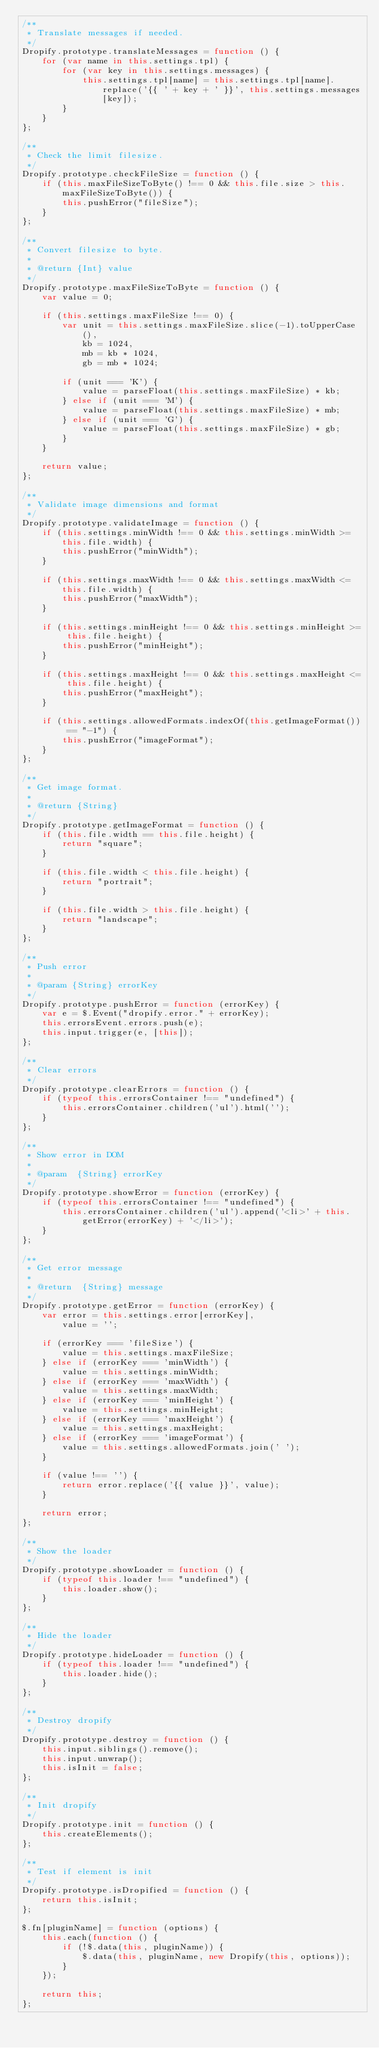<code> <loc_0><loc_0><loc_500><loc_500><_JavaScript_>/**
 * Translate messages if needed.
 */
Dropify.prototype.translateMessages = function () {
	for (var name in this.settings.tpl) {
		for (var key in this.settings.messages) {
			this.settings.tpl[name] = this.settings.tpl[name].replace('{{ ' + key + ' }}', this.settings.messages[key]);
		}
	}
};

/**
 * Check the limit filesize.
 */
Dropify.prototype.checkFileSize = function () {
	if (this.maxFileSizeToByte() !== 0 && this.file.size > this.maxFileSizeToByte()) {
		this.pushError("fileSize");
	}
};

/**
 * Convert filesize to byte.
 *
 * @return {Int} value
 */
Dropify.prototype.maxFileSizeToByte = function () {
	var value = 0;

	if (this.settings.maxFileSize !== 0) {
		var unit = this.settings.maxFileSize.slice(-1).toUpperCase(),
			kb = 1024,
			mb = kb * 1024,
			gb = mb * 1024;

		if (unit === 'K') {
			value = parseFloat(this.settings.maxFileSize) * kb;
		} else if (unit === 'M') {
			value = parseFloat(this.settings.maxFileSize) * mb;
		} else if (unit === 'G') {
			value = parseFloat(this.settings.maxFileSize) * gb;
		}
	}

	return value;
};

/**
 * Validate image dimensions and format
 */
Dropify.prototype.validateImage = function () {
	if (this.settings.minWidth !== 0 && this.settings.minWidth >= this.file.width) {
		this.pushError("minWidth");
	}

	if (this.settings.maxWidth !== 0 && this.settings.maxWidth <= this.file.width) {
		this.pushError("maxWidth");
	}

	if (this.settings.minHeight !== 0 && this.settings.minHeight >= this.file.height) {
		this.pushError("minHeight");
	}

	if (this.settings.maxHeight !== 0 && this.settings.maxHeight <= this.file.height) {
		this.pushError("maxHeight");
	}

	if (this.settings.allowedFormats.indexOf(this.getImageFormat()) == "-1") {
		this.pushError("imageFormat");
	}
};

/**
 * Get image format.
 *
 * @return {String}
 */
Dropify.prototype.getImageFormat = function () {
	if (this.file.width == this.file.height) {
		return "square";
	}

	if (this.file.width < this.file.height) {
		return "portrait";
	}

	if (this.file.width > this.file.height) {
		return "landscape";
	}
};

/**
 * Push error
 *
 * @param {String} errorKey
 */
Dropify.prototype.pushError = function (errorKey) {
	var e = $.Event("dropify.error." + errorKey);
	this.errorsEvent.errors.push(e);
	this.input.trigger(e, [this]);
};

/**
 * Clear errors
 */
Dropify.prototype.clearErrors = function () {
	if (typeof this.errorsContainer !== "undefined") {
		this.errorsContainer.children('ul').html('');
	}
};

/**
 * Show error in DOM
 *
 * @param  {String} errorKey
 */
Dropify.prototype.showError = function (errorKey) {
	if (typeof this.errorsContainer !== "undefined") {
		this.errorsContainer.children('ul').append('<li>' + this.getError(errorKey) + '</li>');
	}
};

/**
 * Get error message
 *
 * @return  {String} message
 */
Dropify.prototype.getError = function (errorKey) {
	var error = this.settings.error[errorKey],
		value = '';

	if (errorKey === 'fileSize') {
		value = this.settings.maxFileSize;
	} else if (errorKey === 'minWidth') {
		value = this.settings.minWidth;
	} else if (errorKey === 'maxWidth') {
		value = this.settings.maxWidth;
	} else if (errorKey === 'minHeight') {
		value = this.settings.minHeight;
	} else if (errorKey === 'maxHeight') {
		value = this.settings.maxHeight;
	} else if (errorKey === 'imageFormat') {
		value = this.settings.allowedFormats.join(' ');
	}

	if (value !== '') {
		return error.replace('{{ value }}', value);
	}

	return error;
};

/**
 * Show the loader
 */
Dropify.prototype.showLoader = function () {
	if (typeof this.loader !== "undefined") {
		this.loader.show();
	}
};

/**
 * Hide the loader
 */
Dropify.prototype.hideLoader = function () {
	if (typeof this.loader !== "undefined") {
		this.loader.hide();
	}
};

/**
 * Destroy dropify
 */
Dropify.prototype.destroy = function () {
	this.input.siblings().remove();
	this.input.unwrap();
	this.isInit = false;
};

/**
 * Init dropify
 */
Dropify.prototype.init = function () {
	this.createElements();
};

/**
 * Test if element is init
 */
Dropify.prototype.isDropified = function () {
	return this.isInit;
};

$.fn[pluginName] = function (options) {
	this.each(function () {
		if (!$.data(this, pluginName)) {
			$.data(this, pluginName, new Dropify(this, options));
		}
	});

	return this;
};</code> 